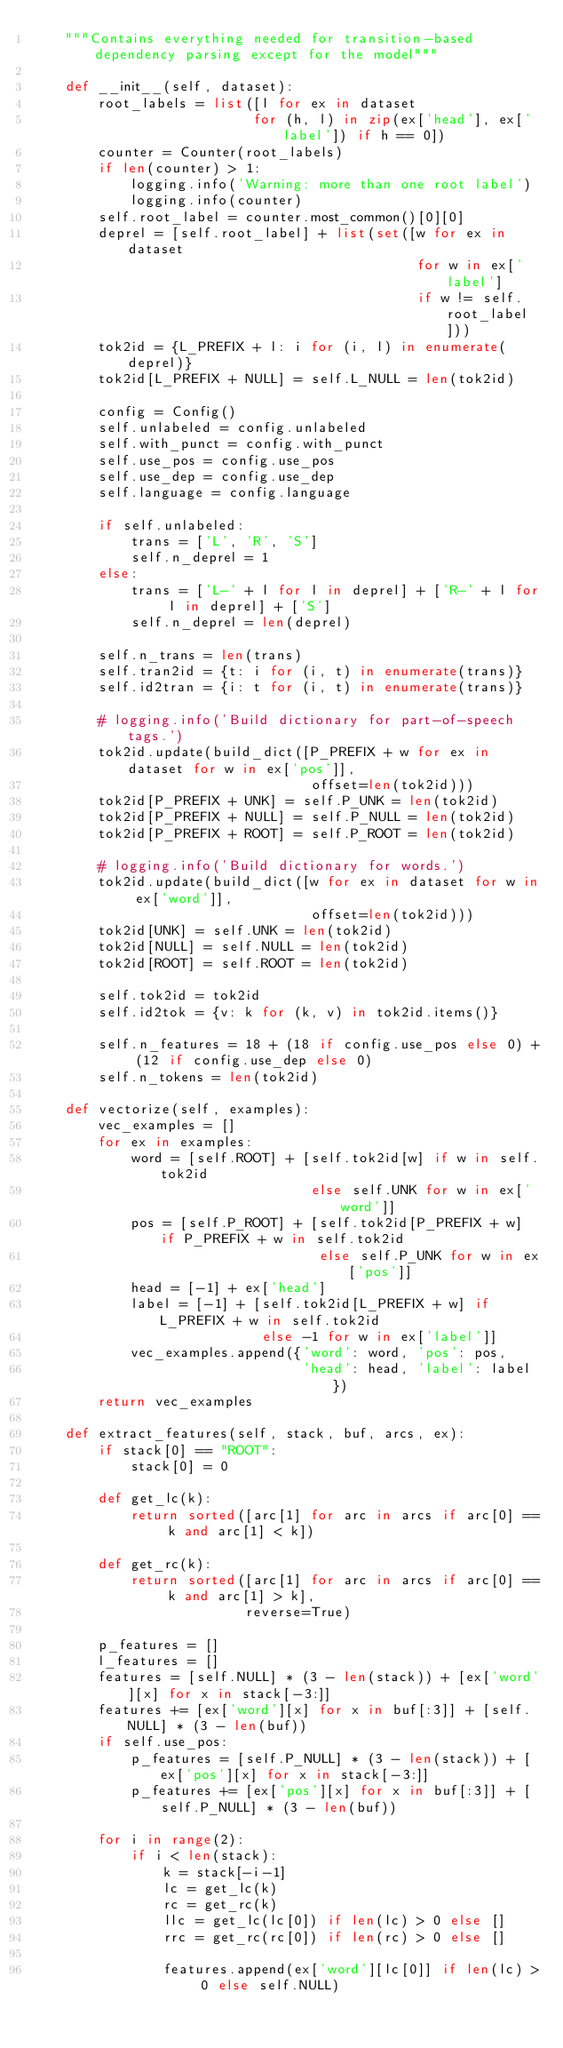Convert code to text. <code><loc_0><loc_0><loc_500><loc_500><_Python_>    """Contains everything needed for transition-based dependency parsing except for the model"""

    def __init__(self, dataset):
        root_labels = list([l for ex in dataset
                           for (h, l) in zip(ex['head'], ex['label']) if h == 0])
        counter = Counter(root_labels)
        if len(counter) > 1:
            logging.info('Warning: more than one root label')
            logging.info(counter)
        self.root_label = counter.most_common()[0][0]
        deprel = [self.root_label] + list(set([w for ex in dataset
                                               for w in ex['label']
                                               if w != self.root_label]))
        tok2id = {L_PREFIX + l: i for (i, l) in enumerate(deprel)}
        tok2id[L_PREFIX + NULL] = self.L_NULL = len(tok2id)

        config = Config()
        self.unlabeled = config.unlabeled
        self.with_punct = config.with_punct
        self.use_pos = config.use_pos
        self.use_dep = config.use_dep
        self.language = config.language

        if self.unlabeled:
            trans = ['L', 'R', 'S']
            self.n_deprel = 1
        else:
            trans = ['L-' + l for l in deprel] + ['R-' + l for l in deprel] + ['S']
            self.n_deprel = len(deprel)

        self.n_trans = len(trans)
        self.tran2id = {t: i for (i, t) in enumerate(trans)}
        self.id2tran = {i: t for (i, t) in enumerate(trans)}

        # logging.info('Build dictionary for part-of-speech tags.')
        tok2id.update(build_dict([P_PREFIX + w for ex in dataset for w in ex['pos']],
                                  offset=len(tok2id)))
        tok2id[P_PREFIX + UNK] = self.P_UNK = len(tok2id)
        tok2id[P_PREFIX + NULL] = self.P_NULL = len(tok2id)
        tok2id[P_PREFIX + ROOT] = self.P_ROOT = len(tok2id)

        # logging.info('Build dictionary for words.')
        tok2id.update(build_dict([w for ex in dataset for w in ex['word']],
                                  offset=len(tok2id)))
        tok2id[UNK] = self.UNK = len(tok2id)
        tok2id[NULL] = self.NULL = len(tok2id)
        tok2id[ROOT] = self.ROOT = len(tok2id)

        self.tok2id = tok2id
        self.id2tok = {v: k for (k, v) in tok2id.items()}

        self.n_features = 18 + (18 if config.use_pos else 0) + (12 if config.use_dep else 0)
        self.n_tokens = len(tok2id)

    def vectorize(self, examples):
        vec_examples = []
        for ex in examples:
            word = [self.ROOT] + [self.tok2id[w] if w in self.tok2id
                                  else self.UNK for w in ex['word']]
            pos = [self.P_ROOT] + [self.tok2id[P_PREFIX + w] if P_PREFIX + w in self.tok2id
                                   else self.P_UNK for w in ex['pos']]
            head = [-1] + ex['head']
            label = [-1] + [self.tok2id[L_PREFIX + w] if L_PREFIX + w in self.tok2id
                            else -1 for w in ex['label']]
            vec_examples.append({'word': word, 'pos': pos,
                                 'head': head, 'label': label})
        return vec_examples

    def extract_features(self, stack, buf, arcs, ex):
        if stack[0] == "ROOT":
            stack[0] = 0

        def get_lc(k):
            return sorted([arc[1] for arc in arcs if arc[0] == k and arc[1] < k])

        def get_rc(k):
            return sorted([arc[1] for arc in arcs if arc[0] == k and arc[1] > k],
                          reverse=True)

        p_features = []
        l_features = []
        features = [self.NULL] * (3 - len(stack)) + [ex['word'][x] for x in stack[-3:]]
        features += [ex['word'][x] for x in buf[:3]] + [self.NULL] * (3 - len(buf))
        if self.use_pos:
            p_features = [self.P_NULL] * (3 - len(stack)) + [ex['pos'][x] for x in stack[-3:]]
            p_features += [ex['pos'][x] for x in buf[:3]] + [self.P_NULL] * (3 - len(buf))

        for i in range(2):
            if i < len(stack):
                k = stack[-i-1]
                lc = get_lc(k)
                rc = get_rc(k)
                llc = get_lc(lc[0]) if len(lc) > 0 else []
                rrc = get_rc(rc[0]) if len(rc) > 0 else []

                features.append(ex['word'][lc[0]] if len(lc) > 0 else self.NULL)</code> 